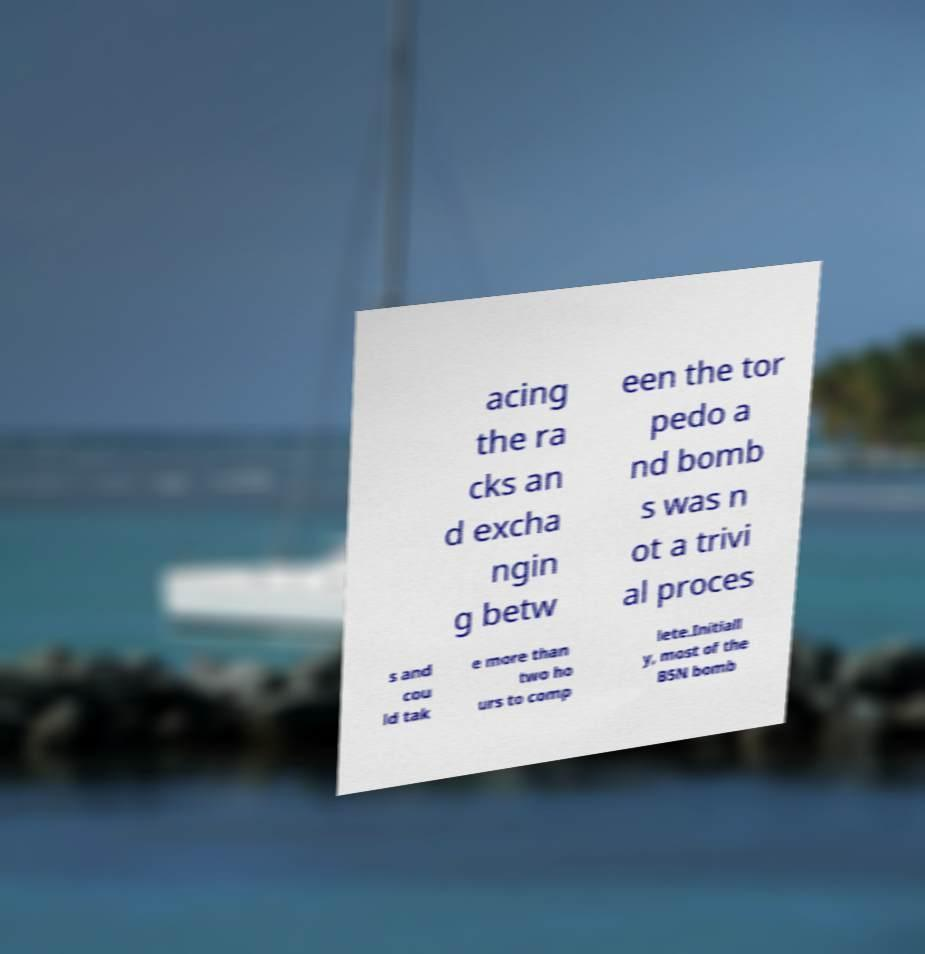I need the written content from this picture converted into text. Can you do that? acing the ra cks an d excha ngin g betw een the tor pedo a nd bomb s was n ot a trivi al proces s and cou ld tak e more than two ho urs to comp lete.Initiall y, most of the B5N bomb 